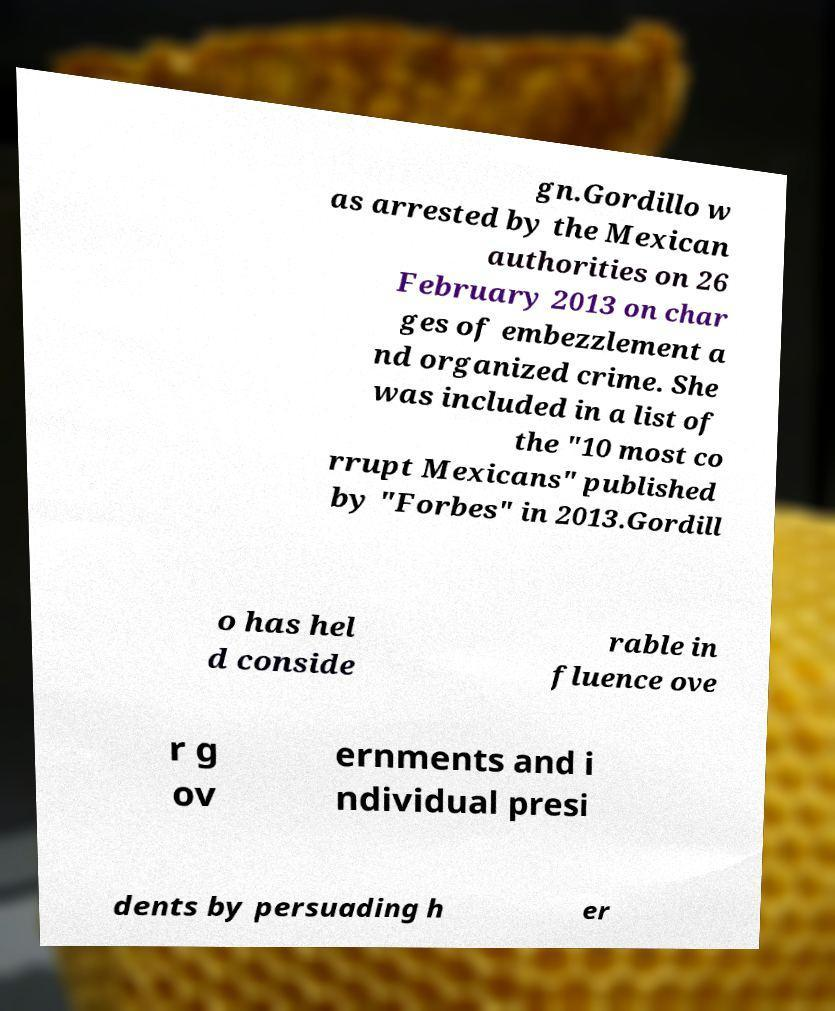Could you extract and type out the text from this image? gn.Gordillo w as arrested by the Mexican authorities on 26 February 2013 on char ges of embezzlement a nd organized crime. She was included in a list of the "10 most co rrupt Mexicans" published by "Forbes" in 2013.Gordill o has hel d conside rable in fluence ove r g ov ernments and i ndividual presi dents by persuading h er 